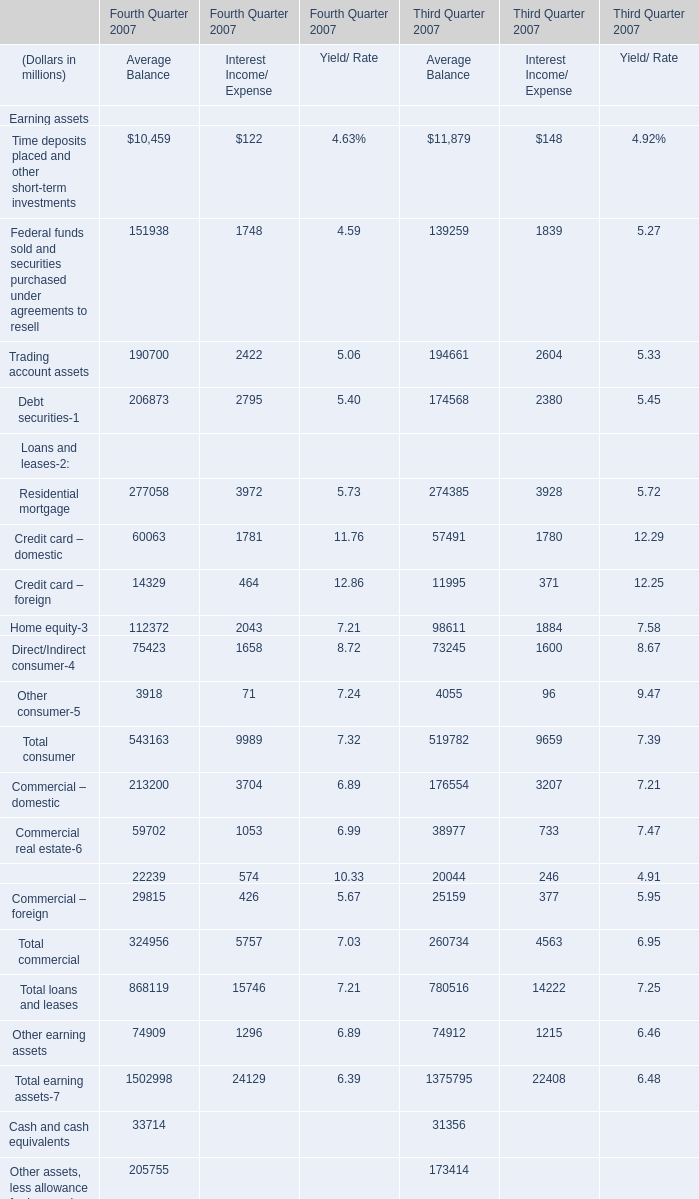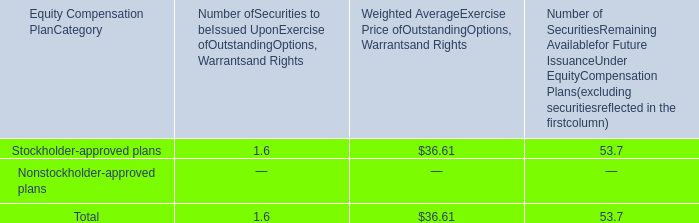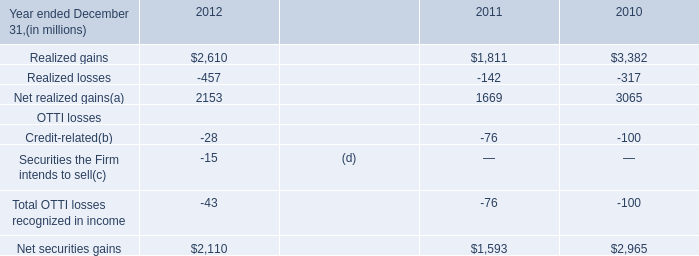What is the ratioof Time deposits placed and other short-term investments of Average Balance to the total in 2007? 
Computations: (10459 / (10459 + 122))
Answer: 0.98847. 